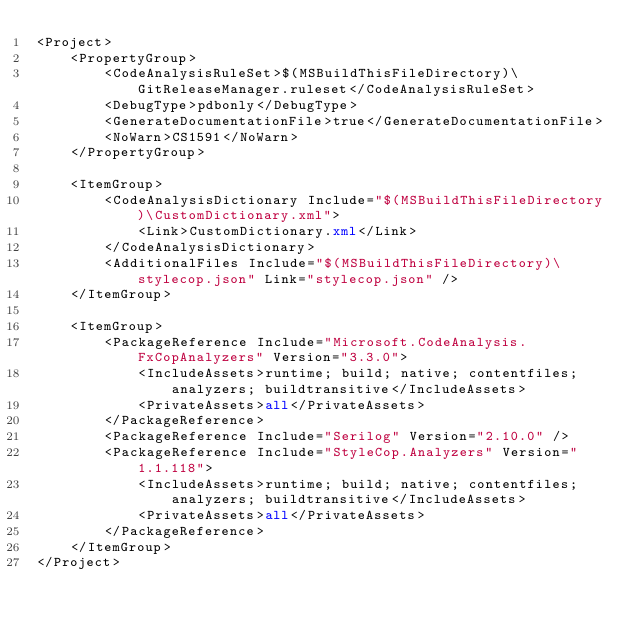<code> <loc_0><loc_0><loc_500><loc_500><_XML_><Project>
    <PropertyGroup>
        <CodeAnalysisRuleSet>$(MSBuildThisFileDirectory)\GitReleaseManager.ruleset</CodeAnalysisRuleSet>
        <DebugType>pdbonly</DebugType>
        <GenerateDocumentationFile>true</GenerateDocumentationFile>
        <NoWarn>CS1591</NoWarn>
    </PropertyGroup>

    <ItemGroup>
        <CodeAnalysisDictionary Include="$(MSBuildThisFileDirectory)\CustomDictionary.xml">
            <Link>CustomDictionary.xml</Link>
        </CodeAnalysisDictionary>
        <AdditionalFiles Include="$(MSBuildThisFileDirectory)\stylecop.json" Link="stylecop.json" />
    </ItemGroup>

    <ItemGroup>
        <PackageReference Include="Microsoft.CodeAnalysis.FxCopAnalyzers" Version="3.3.0">
            <IncludeAssets>runtime; build; native; contentfiles; analyzers; buildtransitive</IncludeAssets>
            <PrivateAssets>all</PrivateAssets>
        </PackageReference>
        <PackageReference Include="Serilog" Version="2.10.0" />
        <PackageReference Include="StyleCop.Analyzers" Version="1.1.118">
            <IncludeAssets>runtime; build; native; contentfiles; analyzers; buildtransitive</IncludeAssets>
            <PrivateAssets>all</PrivateAssets>
        </PackageReference>
    </ItemGroup>
</Project></code> 